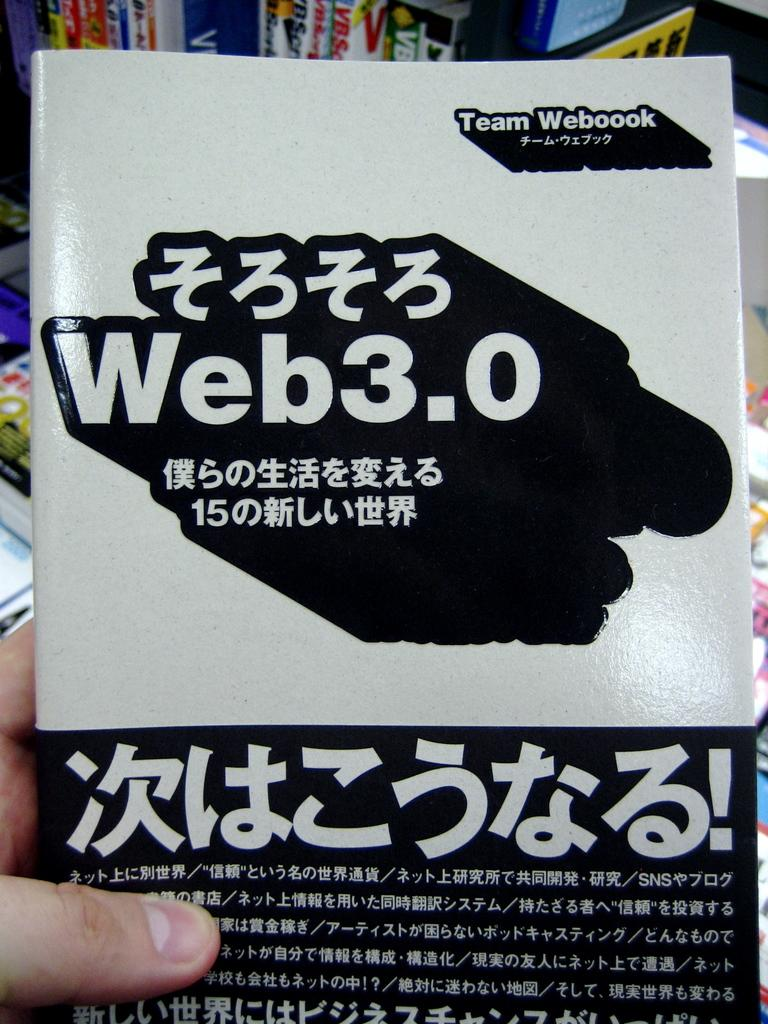<image>
Offer a succinct explanation of the picture presented. A hand is holding a book called Team Webook Web3.0 